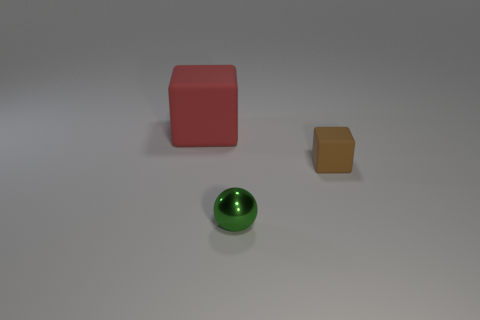Subtract all red cubes. How many cubes are left? 1 Add 2 small yellow things. How many objects exist? 5 Subtract all spheres. How many objects are left? 2 Subtract all red objects. Subtract all tiny gray cylinders. How many objects are left? 2 Add 1 tiny green spheres. How many tiny green spheres are left? 2 Add 3 small brown matte blocks. How many small brown matte blocks exist? 4 Subtract 1 green spheres. How many objects are left? 2 